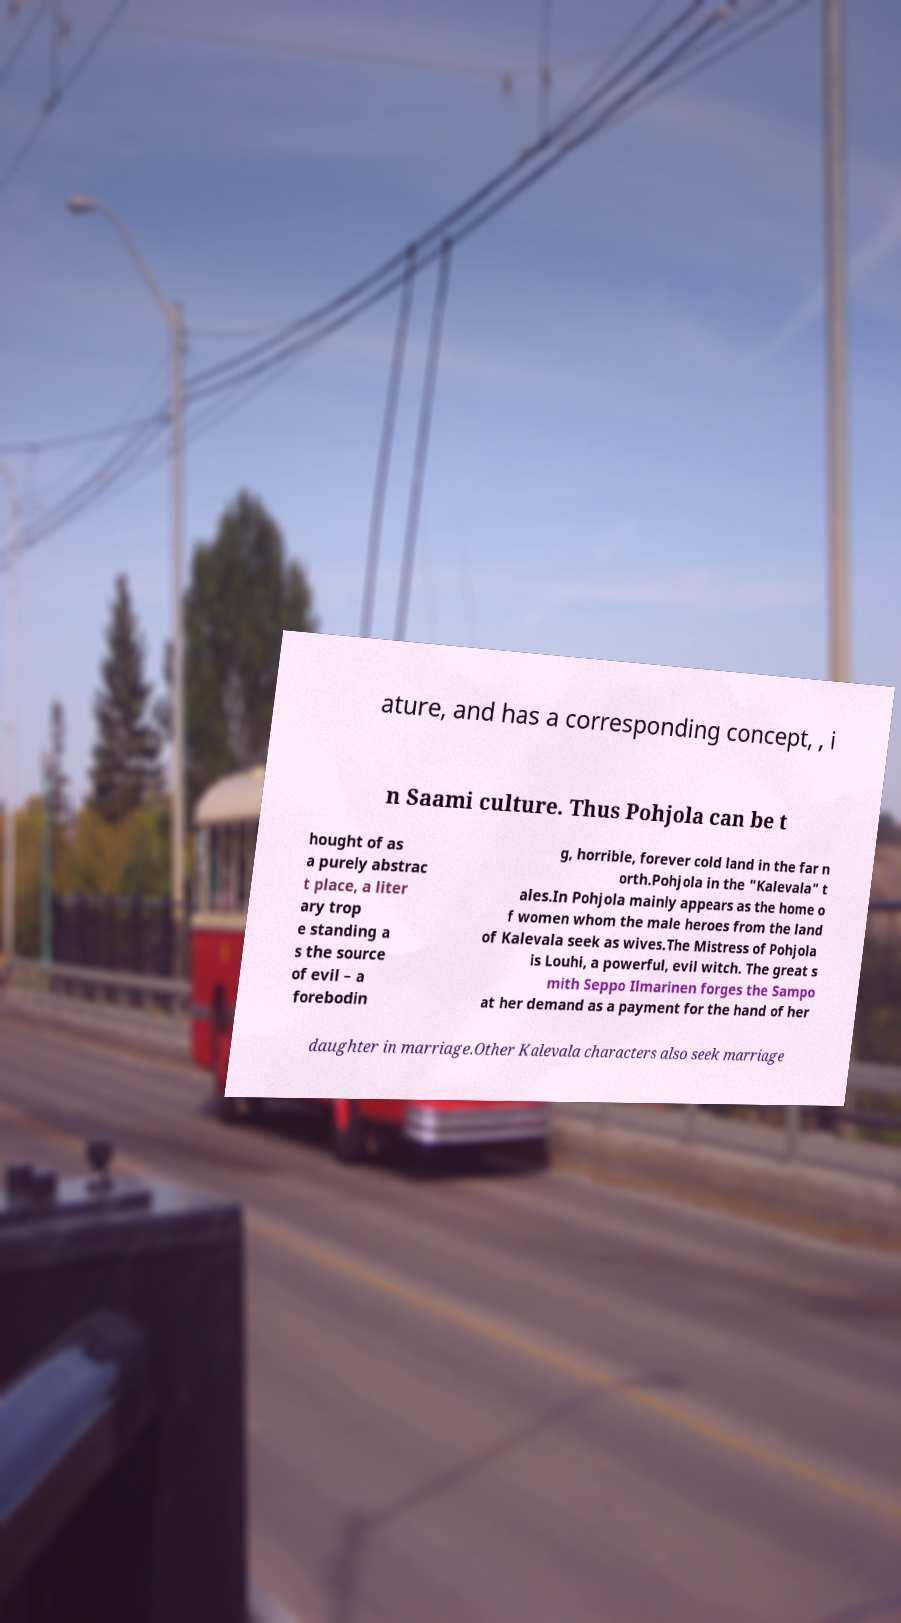There's text embedded in this image that I need extracted. Can you transcribe it verbatim? ature, and has a corresponding concept, , i n Saami culture. Thus Pohjola can be t hought of as a purely abstrac t place, a liter ary trop e standing a s the source of evil – a forebodin g, horrible, forever cold land in the far n orth.Pohjola in the "Kalevala" t ales.In Pohjola mainly appears as the home o f women whom the male heroes from the land of Kalevala seek as wives.The Mistress of Pohjola is Louhi, a powerful, evil witch. The great s mith Seppo Ilmarinen forges the Sampo at her demand as a payment for the hand of her daughter in marriage.Other Kalevala characters also seek marriage 